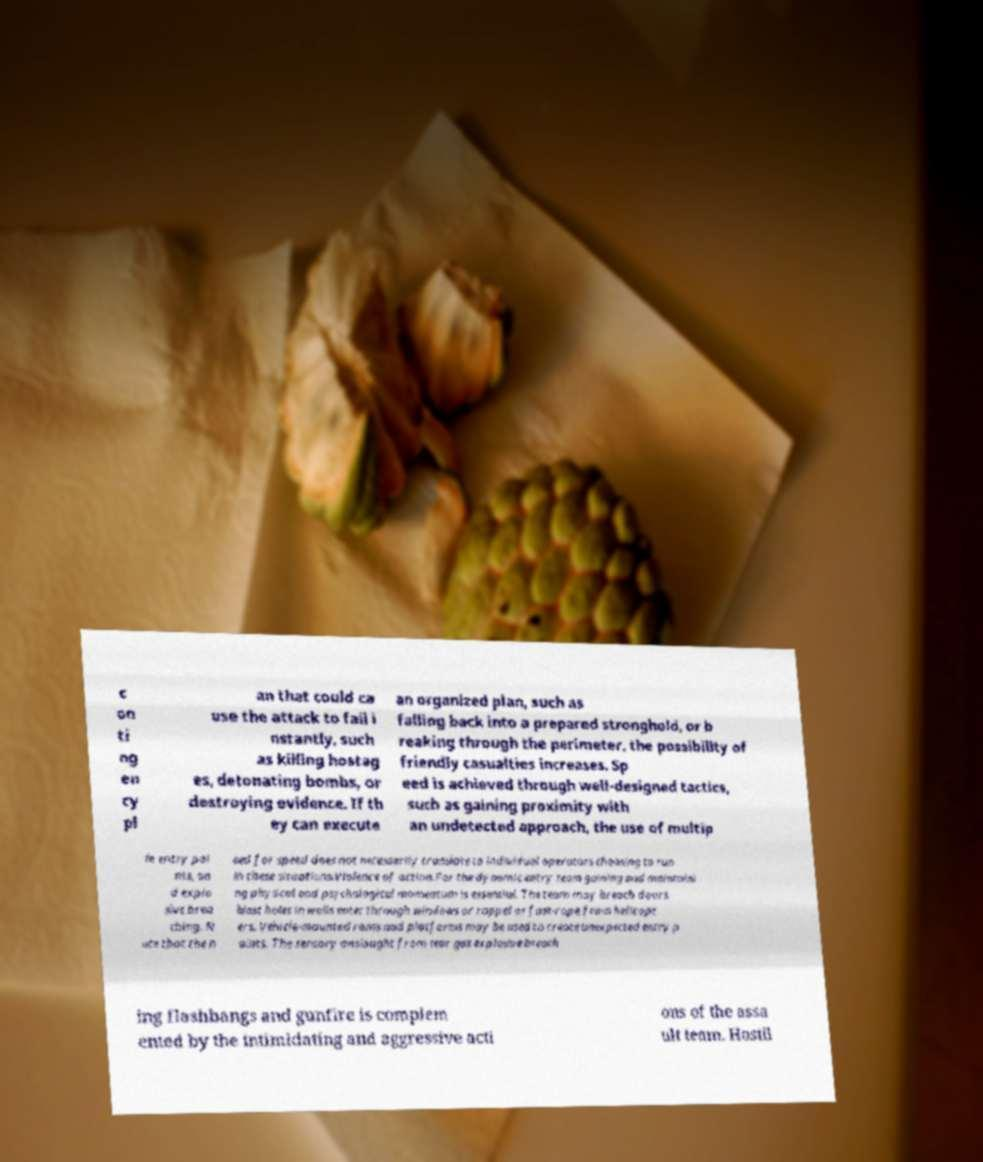I need the written content from this picture converted into text. Can you do that? c on ti ng en cy pl an that could ca use the attack to fail i nstantly, such as killing hostag es, detonating bombs, or destroying evidence. If th ey can execute an organized plan, such as falling back into a prepared stronghold, or b reaking through the perimeter, the possibility of friendly casualties increases. Sp eed is achieved through well-designed tactics, such as gaining proximity with an undetected approach, the use of multip le entry poi nts, an d explo sive brea ching. N ote that the n eed for speed does not necessarily translate to individual operators choosing to run in these situations.Violence of action.For the dynamic entry team gaining and maintaini ng physical and psychological momentum is essential. The team may breach doors blast holes in walls enter through windows or rappel or fast-rope from helicopt ers. Vehicle-mounted rams and platforms may be used to create unexpected entry p oints. The sensory onslaught from tear gas explosive breach ing flashbangs and gunfire is complem ented by the intimidating and aggressive acti ons of the assa ult team. Hostil 